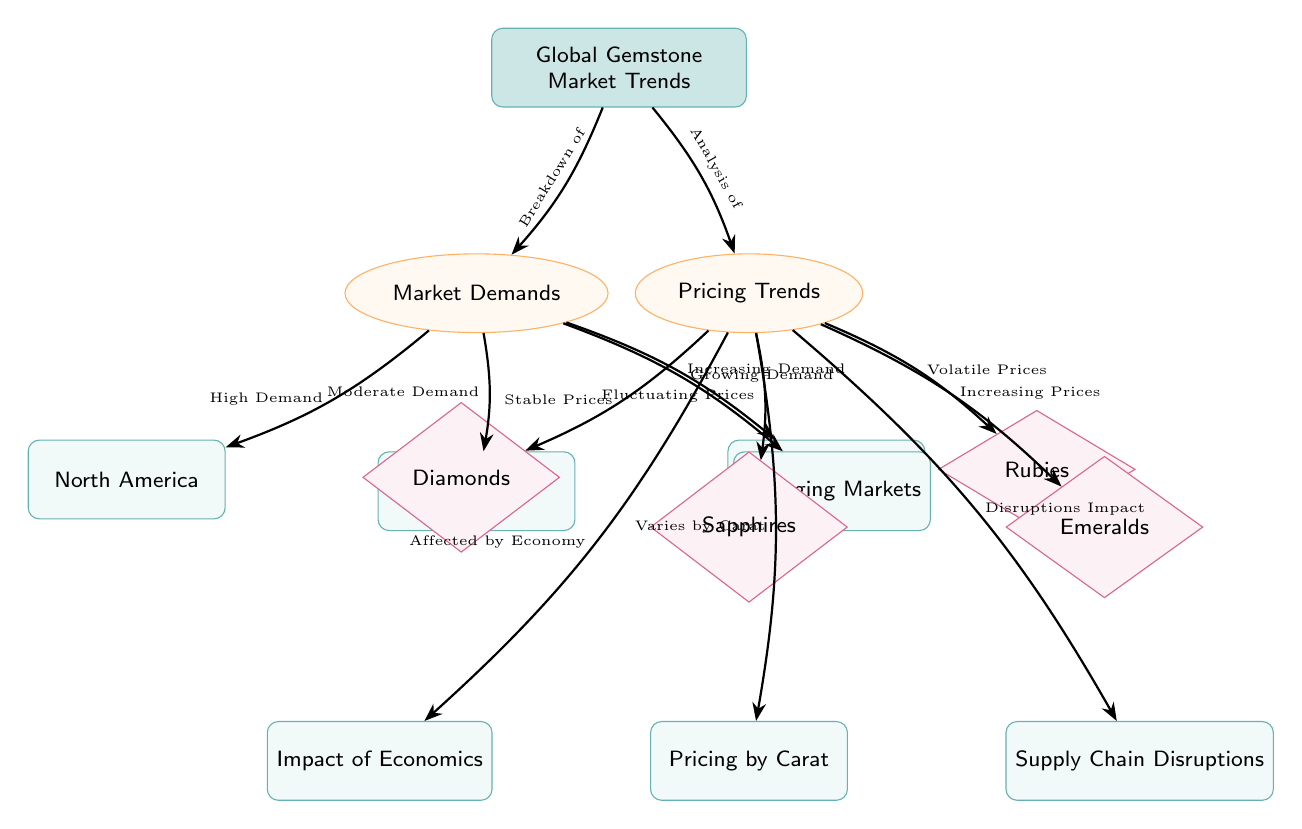What are the four regions listed under Market Demands? The diagram indicates four regions under Market Demands: North America, Europe, Asia-Pacific, and Emerging Markets. These are directly connected from the Market Demands node as specific demands in the global gemstone market.
Answer: North America, Europe, Asia-Pacific, Emerging Markets What type of prices does the diagram associate with diamonds? According to the Pricing Trends section of the diagram, diamonds are associated with Stable Prices, as indicated by the arrow pointing from Pricing Trends to the Diamonds node.
Answer: Stable Prices Which gemstone is linked to Increasing Prices? The diagram indicates that Emeralds are linked to Increasing Prices under the Pricing Trends section, as shown by the arrow connecting them.
Answer: Emeralds What type of demand is indicated for North America? The diagram specifies that North America has High Demand, indicated by the arrow connecting the Market Demands to the North America node.
Answer: High Demand Which factor does the diagram suggest has an impact on pricing by carat? The diagram indicates that Pricing by Carat is affected by the economy, as shown by the arrow connecting to the Economics node from Pricing Trends. This reflects how economic factors can cause variations in pricing based on carat.
Answer: Affected by Economy How many gemstone types are listed in the Pricing Trends section? In the Pricing Trends section, there are four gemstone types listed: Diamonds, Sapphires, Rubies, and Emeralds, which can be seen directly under the Pricing Trends node.
Answer: Four What is the relationship between Supply Chain Disruptions and Pricing Trends? The diagram shows that Supply Chain Disruptions impact the Pricing Trends, as indicated by the arrow connecting from Pricing Trends to the Supply Chain Disruptions node. This suggests that disruptions in the supply chain can lead to variations in gemstone pricing.
Answer: Disruptions Impact How is the demand characterized for the Asia-Pacific region? The diagram characterizes the demand for the Asia-Pacific region as Increasing Demand, as shown by the arrow leading from Market Demands to the Asia-Pacific node.
Answer: Increasing Demand What are the two types of pricing trends indicated for sapphires? The diagram shows that sapphires have Fluctuating Prices, which indicates they do not have a consistent price trend. This is indicated by the arrow pointing from Pricing Trends to the Sapphires node.
Answer: Fluctuating Prices 